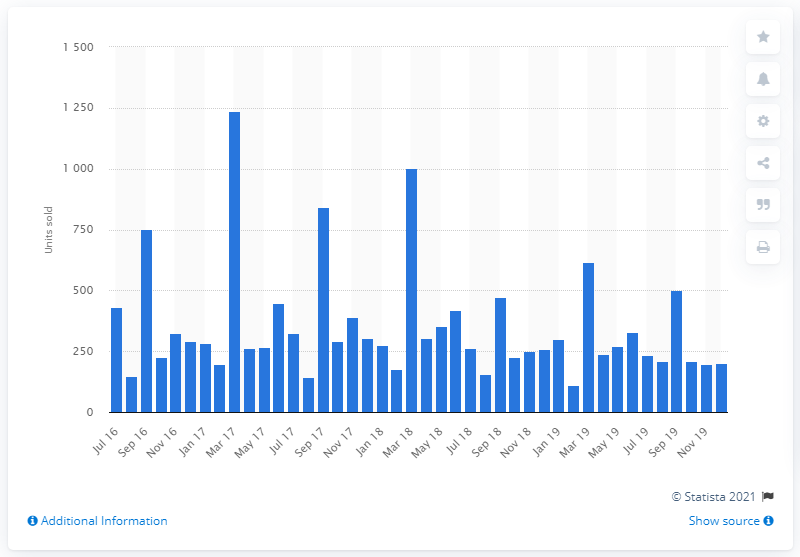Point out several critical features in this image. In July 2019, a total of 235 units of Alfa Romeo cars were sold. 